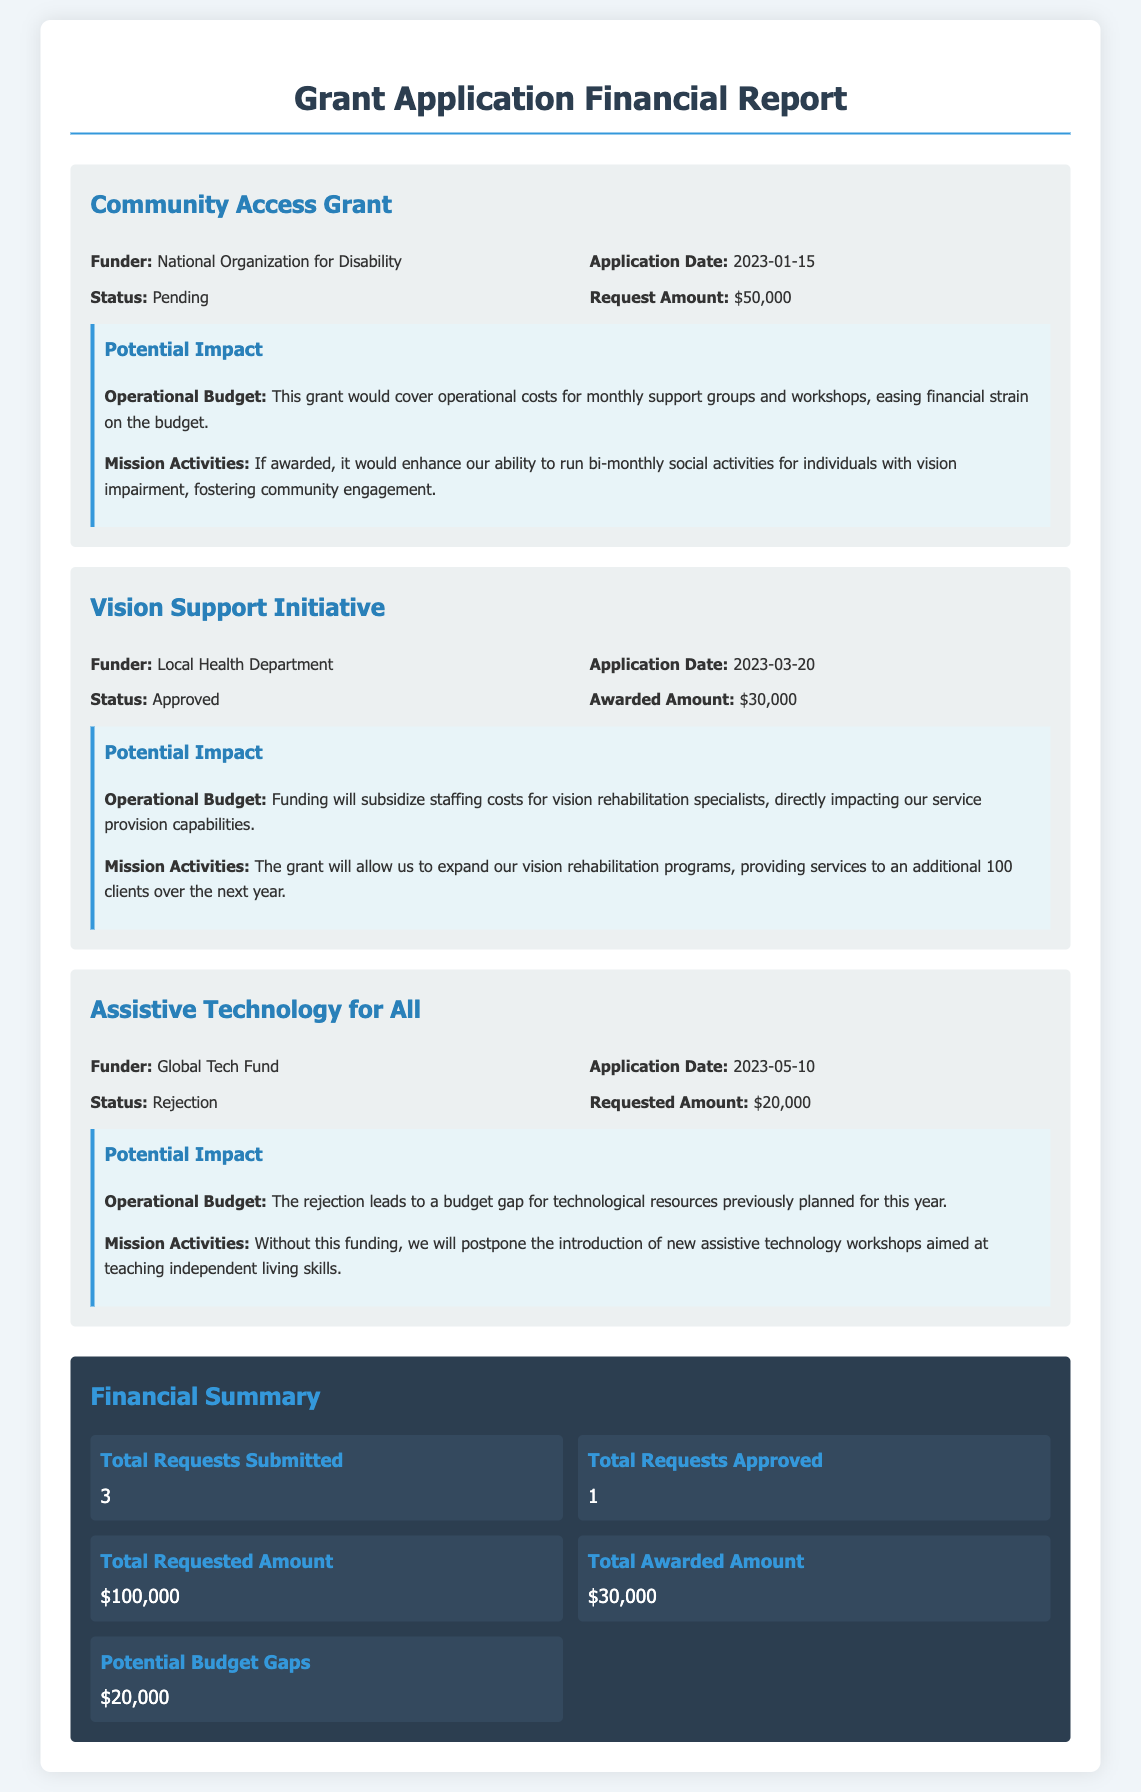What is the title of the report? The title of the report is specified at the top of the document.
Answer: Grant Application Financial Report How many grants have been applied for? The total number of grants can be found in the financial summary section of the document.
Answer: 3 What is the amount requested for the Community Access Grant? The amount requested is detailed under the grant summary for the Community Access Grant.
Answer: $50,000 What is the status of the Assistive Technology for All grant? The status of each grant application is indicated in the associated grant summary.
Answer: Rejection Who funded the Vision Support Initiative? The funder for each grant is stated in the grant details section of the document.
Answer: Local Health Department How much funding has been awarded in total? The total awarded amount is summarized at the end of the report.
Answer: $30,000 What potential budget gap is identified in the report? The potential budget gap is calculated within the financial summary section, taking into account the grants applied for and awarded.
Answer: $20,000 How many requests were approved? The number of approved requests can be found in the totals section, showing the outcomes of the grant applications.
Answer: 1 What is the potential impact on operational budget from the Vision Support Initiative? The potential impact on the operational budget is summarized in the impact section of the Vision Support Initiative grant.
Answer: Funding will subsidize staffing costs 